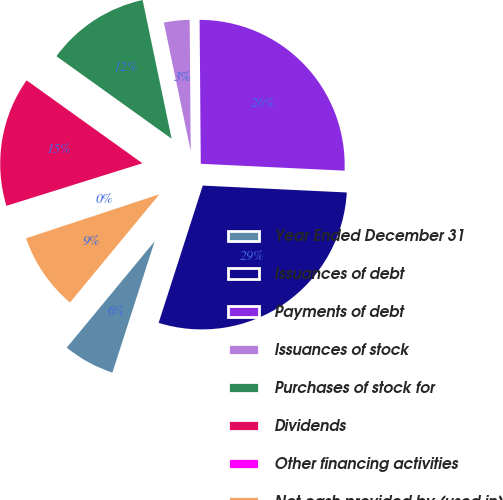Convert chart. <chart><loc_0><loc_0><loc_500><loc_500><pie_chart><fcel>Year Ended December 31<fcel>Issuances of debt<fcel>Payments of debt<fcel>Issuances of stock<fcel>Purchases of stock for<fcel>Dividends<fcel>Other financing activities<fcel>Net cash provided by (used in)<nl><fcel>6.04%<fcel>29.19%<fcel>25.89%<fcel>3.15%<fcel>11.83%<fcel>14.72%<fcel>0.25%<fcel>8.93%<nl></chart> 